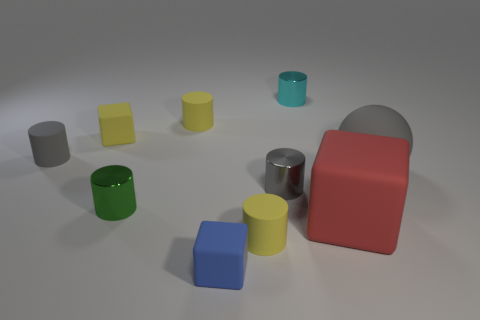Can you describe the shapes and colors present in the image? Certainly! The image displays a collection of geometric shapes in various colors. There are cylinders in green, yellow, and gray; cubes in yellow, blue, and gray; and a rectangular prism that's red. The colors are vivid and set against a neutral background. 